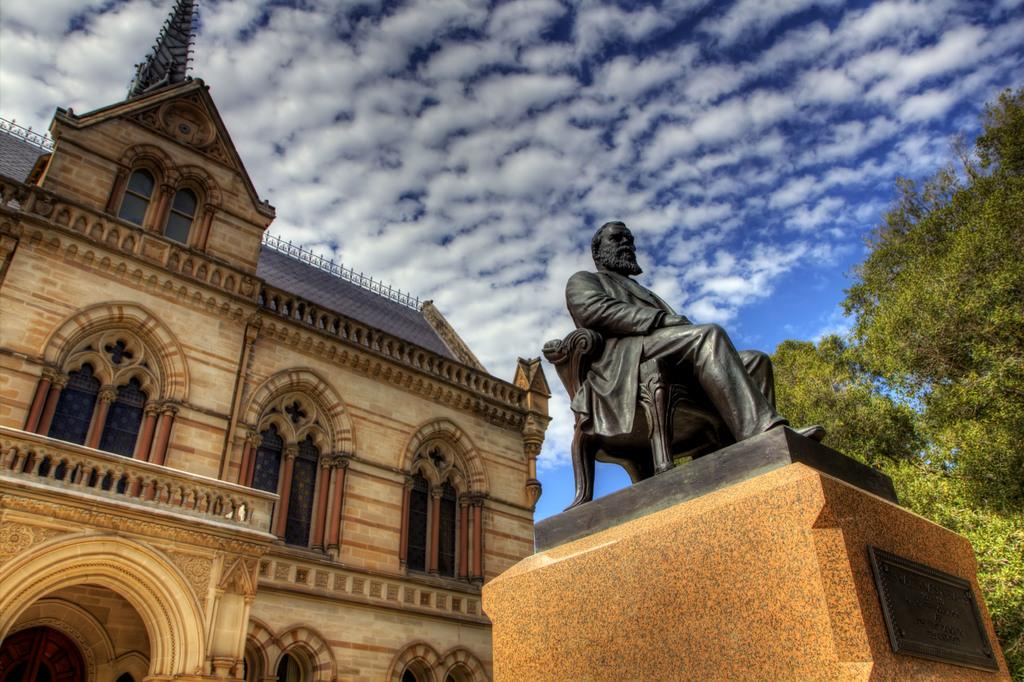What is the main structure in the image? There is a building in the image. What is located in front of the building? There is a sculpture of a person in front of the building. What is the color of the sculpture? The sculpture is black in color. What is beside the sculpture? There is a tree beside the sculpture. What can be seen in the background of the image? The sky is visible in the background of the image. How many birds are perched on the hydrant in the image? There is no hydrant present in the image, and therefore no birds can be observed on it. 